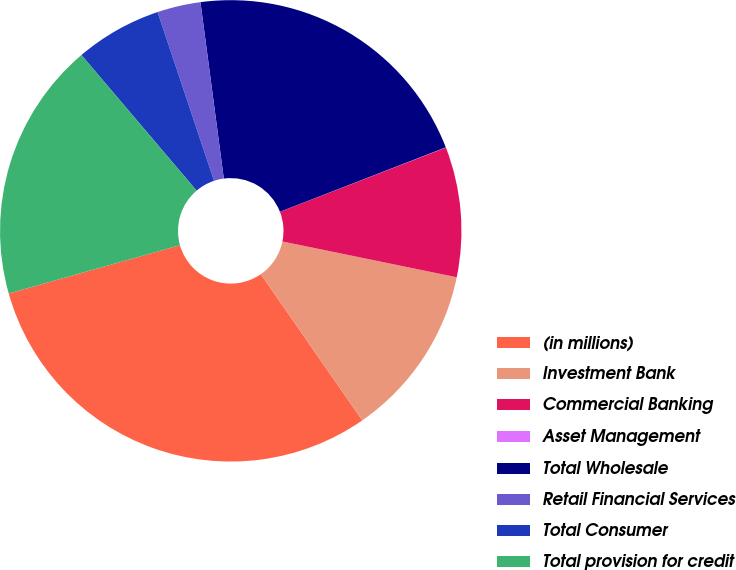Convert chart. <chart><loc_0><loc_0><loc_500><loc_500><pie_chart><fcel>(in millions)<fcel>Investment Bank<fcel>Commercial Banking<fcel>Asset Management<fcel>Total Wholesale<fcel>Retail Financial Services<fcel>Total Consumer<fcel>Total provision for credit<nl><fcel>30.28%<fcel>12.12%<fcel>9.1%<fcel>0.02%<fcel>21.2%<fcel>3.04%<fcel>6.07%<fcel>18.17%<nl></chart> 